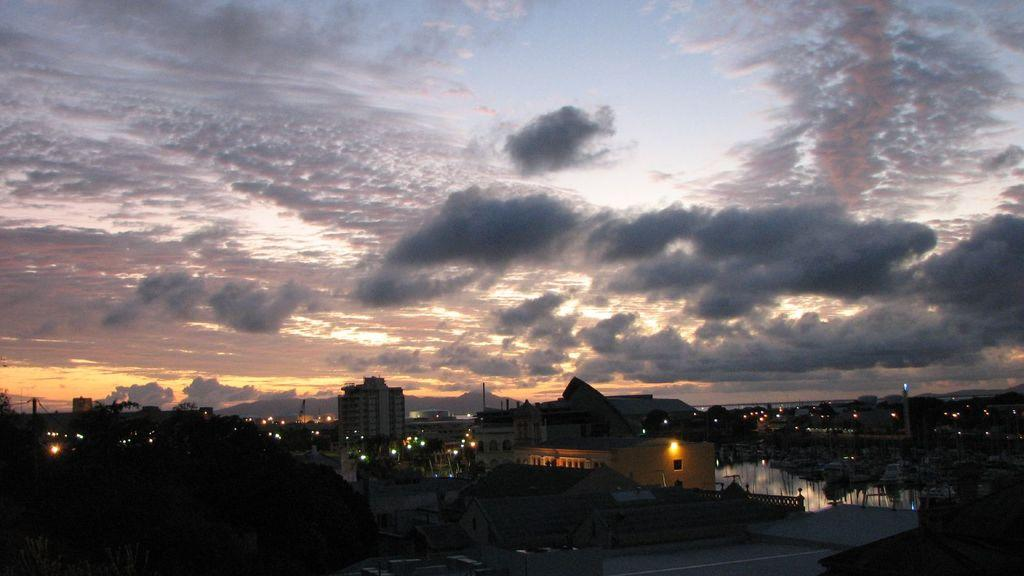What event is taking place in the image? The image depicts a sunset. What type of structures can be seen in the image? There are many houses in the image. What part of the natural environment is visible in the image? The sky is visible in the background of the image. What type of fire can be seen in the image? There is no fire present in the image; it depicts a sunset and houses. 